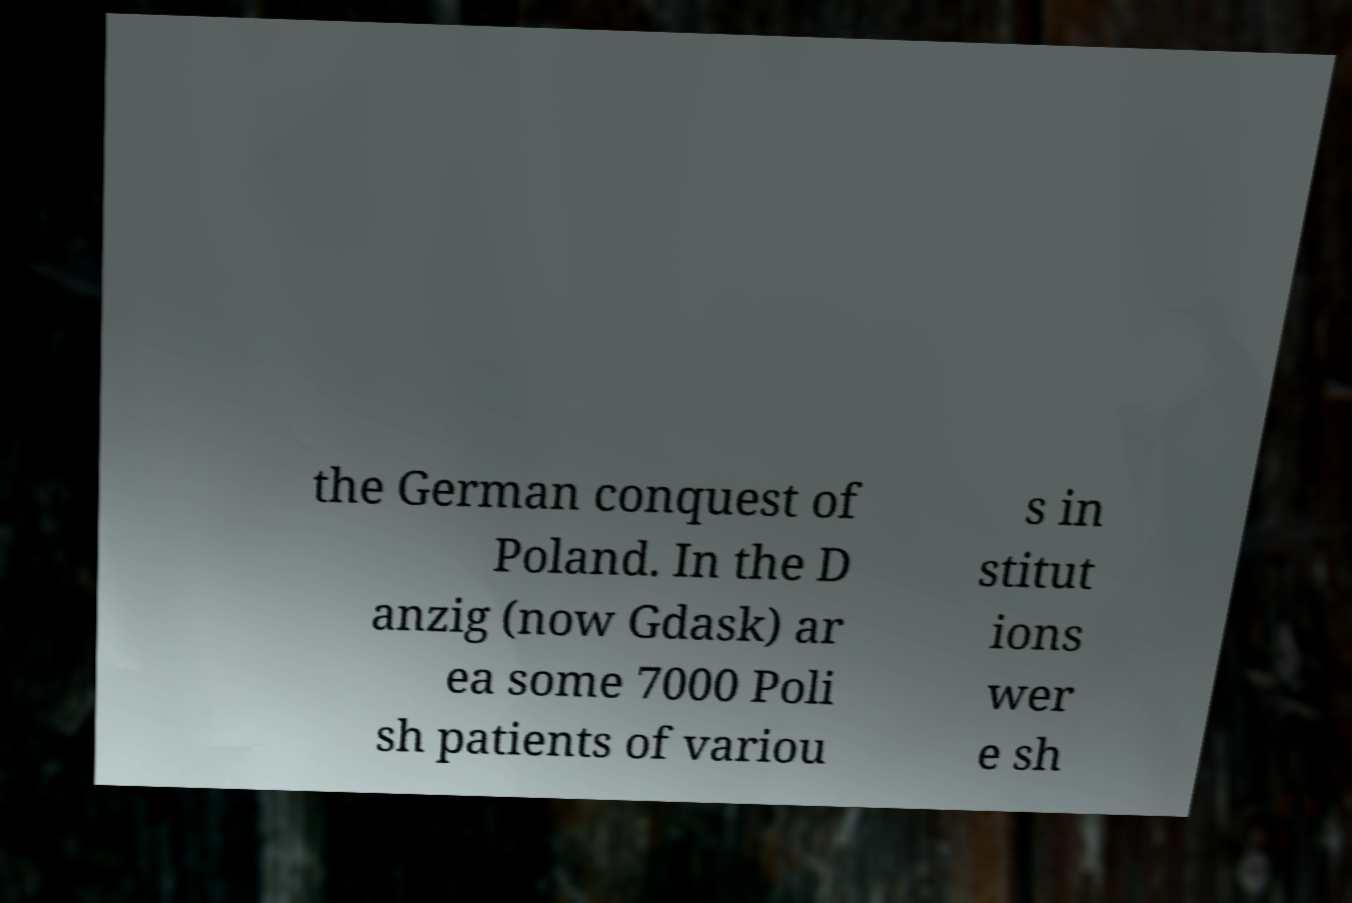Could you extract and type out the text from this image? the German conquest of Poland. In the D anzig (now Gdask) ar ea some 7000 Poli sh patients of variou s in stitut ions wer e sh 